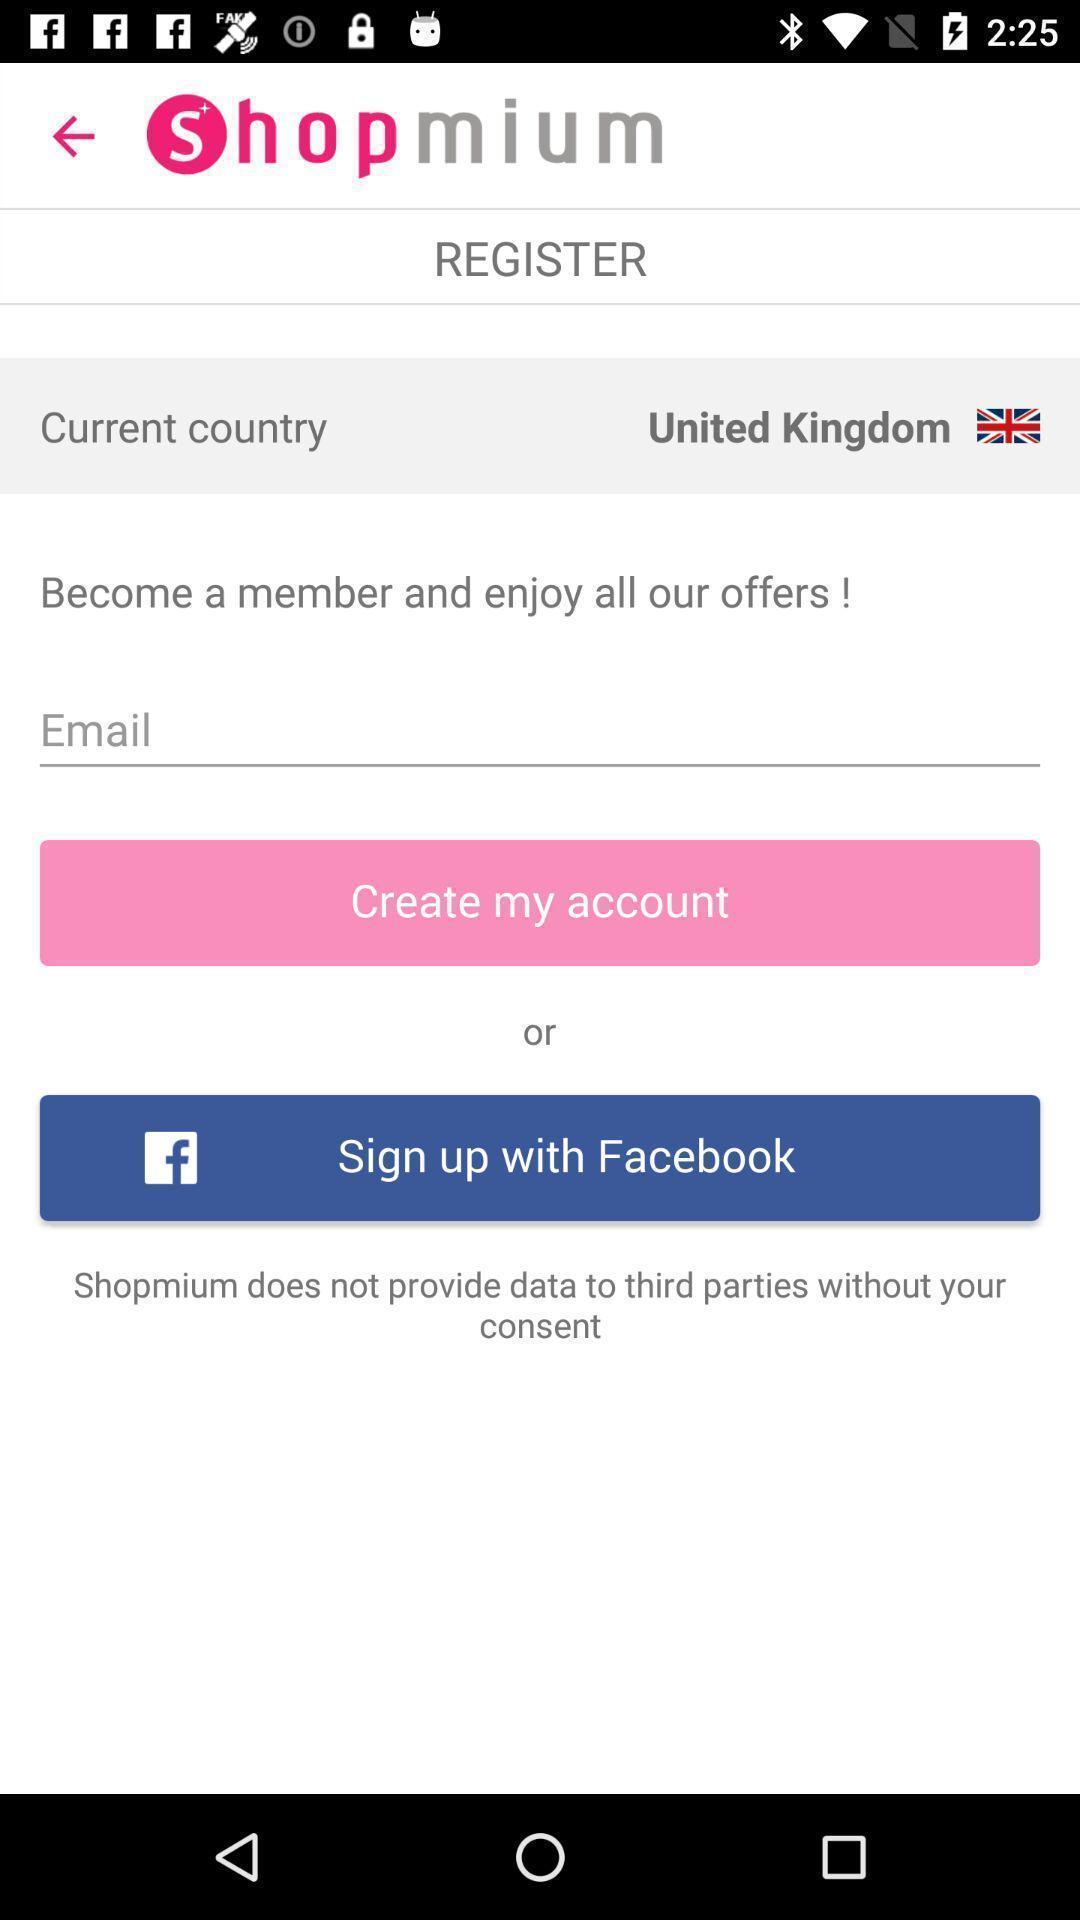Describe this image in words. Welcome page of a shopping app. 